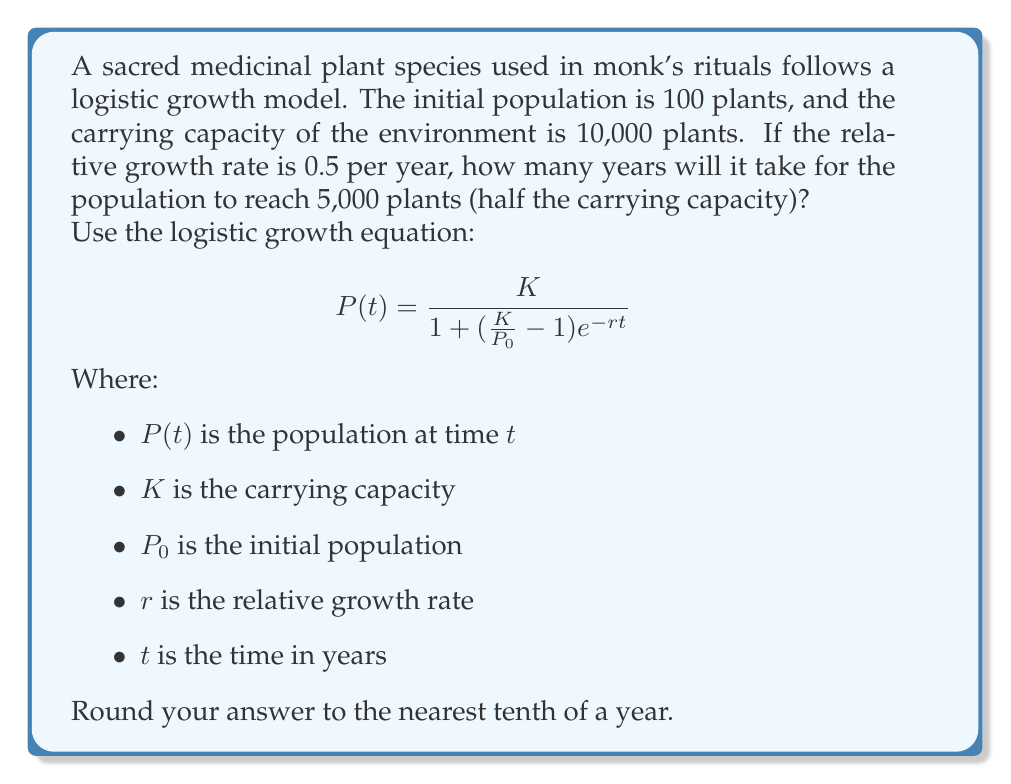What is the answer to this math problem? To solve this problem, we'll use the logistic growth equation and solve for $t$:

1. Given information:
   $K = 10,000$ (carrying capacity)
   $P_0 = 100$ (initial population)
   $r = 0.5$ (relative growth rate)
   $P(t) = 5,000$ (target population, half of carrying capacity)

2. Substitute the values into the logistic growth equation:

   $$5000 = \frac{10000}{1 + (\frac{10000}{100} - 1)e^{-0.5t}}$$

3. Simplify:

   $$5000 = \frac{10000}{1 + 99e^{-0.5t}}$$

4. Multiply both sides by $(1 + 99e^{-0.5t})$:

   $$5000(1 + 99e^{-0.5t}) = 10000$$

5. Expand:

   $$5000 + 495000e^{-0.5t} = 10000$$

6. Subtract 5000 from both sides:

   $$495000e^{-0.5t} = 5000$$

7. Divide both sides by 495000:

   $$e^{-0.5t} = \frac{1}{99}$$

8. Take the natural logarithm of both sides:

   $$-0.5t = \ln(\frac{1}{99})$$

9. Multiply both sides by -2:

   $$t = -2\ln(\frac{1}{99})$$

10. Simplify:

    $$t = 2\ln(99)$$

11. Calculate the result:

    $$t \approx 9.2103$$

12. Round to the nearest tenth:

    $$t \approx 9.2 \text{ years}$$
Answer: It will take approximately 9.2 years for the sacred medicinal plant population to reach 5,000 plants (half the carrying capacity). 